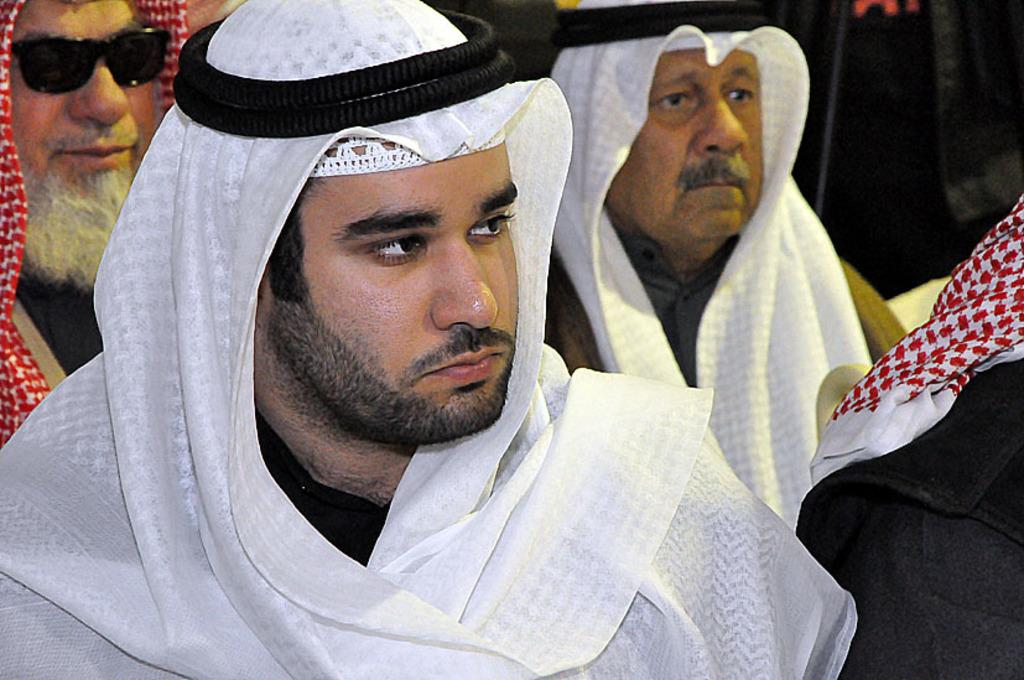What are the people in the image doing? The people in the image are sitting. What type of clothing are the people wearing on their heads? The people are wearing head scarfs. Is it raining in the image? There is no information about the weather in the image, so we cannot determine if it is raining or not. 